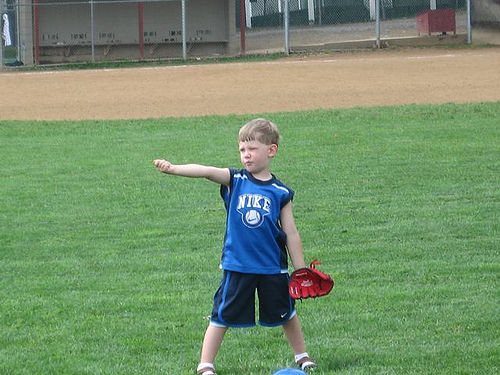Please provide a short description for this region: [0.58, 0.66, 0.66, 0.72]. This region captures the boy's left hand, which is adorned with a striking red baseball glove, likely indicating he's prepared to catch or throw a ball. 